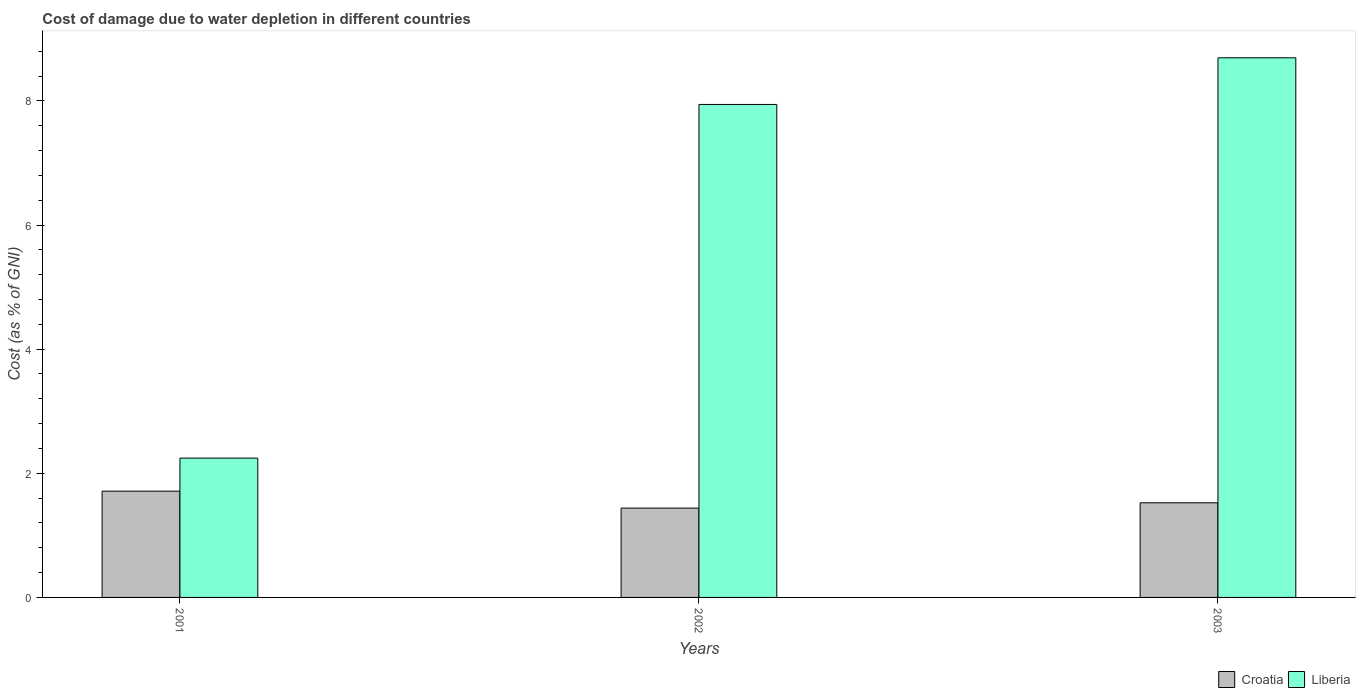How many different coloured bars are there?
Offer a terse response. 2. How many groups of bars are there?
Provide a succinct answer. 3. Are the number of bars on each tick of the X-axis equal?
Keep it short and to the point. Yes. How many bars are there on the 3rd tick from the left?
Your response must be concise. 2. How many bars are there on the 3rd tick from the right?
Keep it short and to the point. 2. What is the cost of damage caused due to water depletion in Liberia in 2001?
Give a very brief answer. 2.24. Across all years, what is the maximum cost of damage caused due to water depletion in Croatia?
Make the answer very short. 1.71. Across all years, what is the minimum cost of damage caused due to water depletion in Croatia?
Your answer should be compact. 1.44. In which year was the cost of damage caused due to water depletion in Liberia minimum?
Ensure brevity in your answer.  2001. What is the total cost of damage caused due to water depletion in Croatia in the graph?
Provide a succinct answer. 4.68. What is the difference between the cost of damage caused due to water depletion in Liberia in 2002 and that in 2003?
Provide a succinct answer. -0.75. What is the difference between the cost of damage caused due to water depletion in Liberia in 2003 and the cost of damage caused due to water depletion in Croatia in 2001?
Ensure brevity in your answer.  6.98. What is the average cost of damage caused due to water depletion in Croatia per year?
Give a very brief answer. 1.56. In the year 2002, what is the difference between the cost of damage caused due to water depletion in Croatia and cost of damage caused due to water depletion in Liberia?
Make the answer very short. -6.5. In how many years, is the cost of damage caused due to water depletion in Liberia greater than 0.8 %?
Keep it short and to the point. 3. What is the ratio of the cost of damage caused due to water depletion in Liberia in 2001 to that in 2002?
Provide a short and direct response. 0.28. Is the cost of damage caused due to water depletion in Croatia in 2001 less than that in 2002?
Your answer should be compact. No. Is the difference between the cost of damage caused due to water depletion in Croatia in 2001 and 2002 greater than the difference between the cost of damage caused due to water depletion in Liberia in 2001 and 2002?
Keep it short and to the point. Yes. What is the difference between the highest and the second highest cost of damage caused due to water depletion in Liberia?
Your response must be concise. 0.75. What is the difference between the highest and the lowest cost of damage caused due to water depletion in Croatia?
Your answer should be very brief. 0.27. In how many years, is the cost of damage caused due to water depletion in Liberia greater than the average cost of damage caused due to water depletion in Liberia taken over all years?
Your answer should be compact. 2. What does the 1st bar from the left in 2001 represents?
Your answer should be compact. Croatia. What does the 2nd bar from the right in 2003 represents?
Keep it short and to the point. Croatia. How many bars are there?
Provide a succinct answer. 6. Are the values on the major ticks of Y-axis written in scientific E-notation?
Offer a very short reply. No. Where does the legend appear in the graph?
Ensure brevity in your answer.  Bottom right. How many legend labels are there?
Make the answer very short. 2. What is the title of the graph?
Make the answer very short. Cost of damage due to water depletion in different countries. Does "Kiribati" appear as one of the legend labels in the graph?
Your response must be concise. No. What is the label or title of the X-axis?
Your response must be concise. Years. What is the label or title of the Y-axis?
Your response must be concise. Cost (as % of GNI). What is the Cost (as % of GNI) of Croatia in 2001?
Ensure brevity in your answer.  1.71. What is the Cost (as % of GNI) in Liberia in 2001?
Offer a very short reply. 2.24. What is the Cost (as % of GNI) of Croatia in 2002?
Your answer should be very brief. 1.44. What is the Cost (as % of GNI) of Liberia in 2002?
Keep it short and to the point. 7.94. What is the Cost (as % of GNI) of Croatia in 2003?
Make the answer very short. 1.52. What is the Cost (as % of GNI) in Liberia in 2003?
Make the answer very short. 8.69. Across all years, what is the maximum Cost (as % of GNI) in Croatia?
Your answer should be very brief. 1.71. Across all years, what is the maximum Cost (as % of GNI) of Liberia?
Offer a terse response. 8.69. Across all years, what is the minimum Cost (as % of GNI) in Croatia?
Provide a short and direct response. 1.44. Across all years, what is the minimum Cost (as % of GNI) of Liberia?
Keep it short and to the point. 2.24. What is the total Cost (as % of GNI) in Croatia in the graph?
Make the answer very short. 4.68. What is the total Cost (as % of GNI) of Liberia in the graph?
Your response must be concise. 18.88. What is the difference between the Cost (as % of GNI) of Croatia in 2001 and that in 2002?
Keep it short and to the point. 0.27. What is the difference between the Cost (as % of GNI) of Liberia in 2001 and that in 2002?
Give a very brief answer. -5.7. What is the difference between the Cost (as % of GNI) of Croatia in 2001 and that in 2003?
Your response must be concise. 0.19. What is the difference between the Cost (as % of GNI) of Liberia in 2001 and that in 2003?
Provide a short and direct response. -6.45. What is the difference between the Cost (as % of GNI) in Croatia in 2002 and that in 2003?
Your answer should be very brief. -0.09. What is the difference between the Cost (as % of GNI) in Liberia in 2002 and that in 2003?
Your answer should be very brief. -0.75. What is the difference between the Cost (as % of GNI) in Croatia in 2001 and the Cost (as % of GNI) in Liberia in 2002?
Your answer should be very brief. -6.23. What is the difference between the Cost (as % of GNI) in Croatia in 2001 and the Cost (as % of GNI) in Liberia in 2003?
Ensure brevity in your answer.  -6.98. What is the difference between the Cost (as % of GNI) of Croatia in 2002 and the Cost (as % of GNI) of Liberia in 2003?
Provide a short and direct response. -7.25. What is the average Cost (as % of GNI) in Croatia per year?
Offer a very short reply. 1.56. What is the average Cost (as % of GNI) in Liberia per year?
Your answer should be very brief. 6.29. In the year 2001, what is the difference between the Cost (as % of GNI) of Croatia and Cost (as % of GNI) of Liberia?
Offer a terse response. -0.53. In the year 2002, what is the difference between the Cost (as % of GNI) of Croatia and Cost (as % of GNI) of Liberia?
Offer a terse response. -6.5. In the year 2003, what is the difference between the Cost (as % of GNI) of Croatia and Cost (as % of GNI) of Liberia?
Provide a short and direct response. -7.17. What is the ratio of the Cost (as % of GNI) in Croatia in 2001 to that in 2002?
Your answer should be compact. 1.19. What is the ratio of the Cost (as % of GNI) in Liberia in 2001 to that in 2002?
Your answer should be compact. 0.28. What is the ratio of the Cost (as % of GNI) in Croatia in 2001 to that in 2003?
Your answer should be compact. 1.12. What is the ratio of the Cost (as % of GNI) of Liberia in 2001 to that in 2003?
Provide a short and direct response. 0.26. What is the ratio of the Cost (as % of GNI) of Croatia in 2002 to that in 2003?
Your response must be concise. 0.94. What is the ratio of the Cost (as % of GNI) in Liberia in 2002 to that in 2003?
Give a very brief answer. 0.91. What is the difference between the highest and the second highest Cost (as % of GNI) in Croatia?
Keep it short and to the point. 0.19. What is the difference between the highest and the second highest Cost (as % of GNI) of Liberia?
Offer a very short reply. 0.75. What is the difference between the highest and the lowest Cost (as % of GNI) in Croatia?
Provide a short and direct response. 0.27. What is the difference between the highest and the lowest Cost (as % of GNI) in Liberia?
Offer a very short reply. 6.45. 